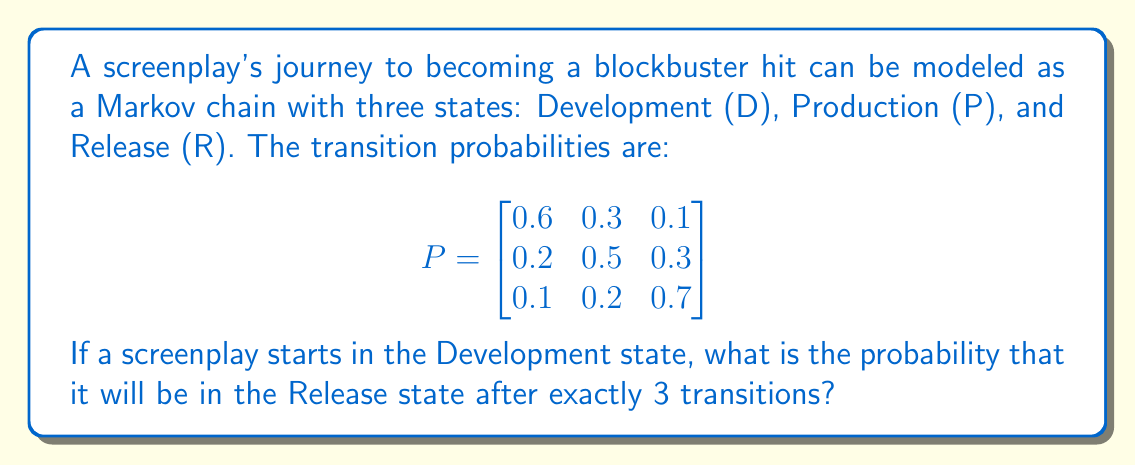Teach me how to tackle this problem. To solve this problem, we need to calculate the 3-step transition probability from the Development state (D) to the Release state (R). We can do this by raising the transition matrix to the power of 3 and looking at the element in the first row, third column.

Step 1: Calculate $P^3$
$$P^3 = P \times P \times P$$

Step 2: Perform matrix multiplication
$$
P^2 = \begin{bmatrix}
0.6 & 0.3 & 0.1 \\
0.2 & 0.5 & 0.3 \\
0.1 & 0.2 & 0.7
\end{bmatrix} \times 
\begin{bmatrix}
0.6 & 0.3 & 0.1 \\
0.2 & 0.5 & 0.3 \\
0.1 & 0.2 & 0.7
\end{bmatrix} = 
\begin{bmatrix}
0.41 & 0.33 & 0.26 \\
0.29 & 0.38 & 0.33 \\
0.19 & 0.29 & 0.52
\end{bmatrix}
$$

$$
P^3 = P^2 \times P = 
\begin{bmatrix}
0.41 & 0.33 & 0.26 \\
0.29 & 0.38 & 0.33 \\
0.19 & 0.29 & 0.52
\end{bmatrix} \times
\begin{bmatrix}
0.6 & 0.3 & 0.1 \\
0.2 & 0.5 & 0.3 \\
0.1 & 0.2 & 0.7
\end{bmatrix} = 
\begin{bmatrix}
0.331 & 0.339 & 0.330 \\
0.281 & 0.353 & 0.366 \\
0.211 & 0.305 & 0.484
\end{bmatrix}
$$

Step 3: Identify the required probability
The probability of being in the Release state (R) after 3 transitions, starting from the Development state (D), is the element in the first row, third column of $P^3$, which is 0.330 or 33.0%.
Answer: 0.330 